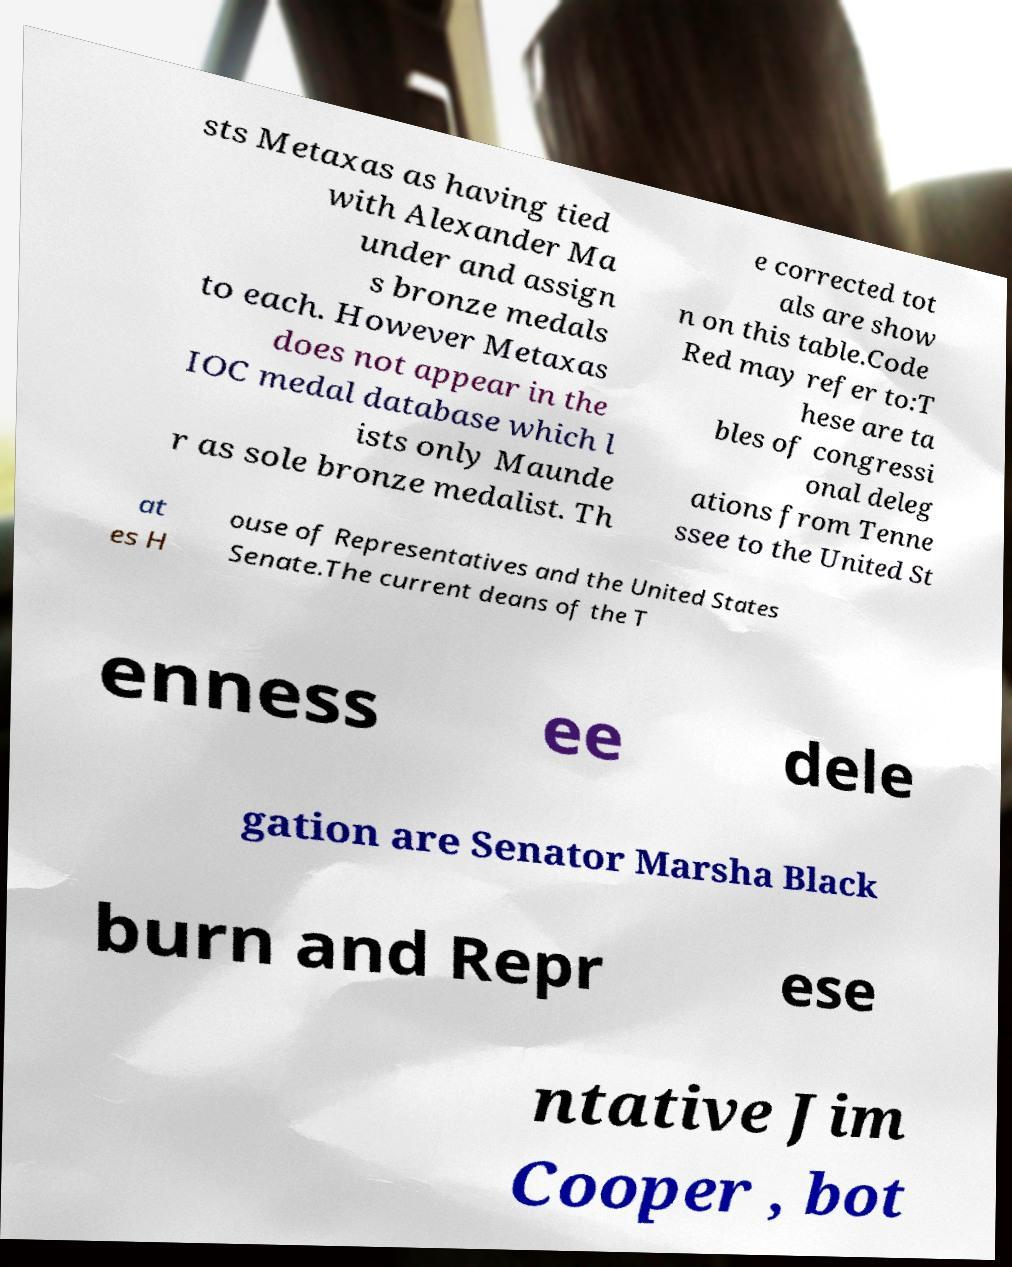What messages or text are displayed in this image? I need them in a readable, typed format. sts Metaxas as having tied with Alexander Ma under and assign s bronze medals to each. However Metaxas does not appear in the IOC medal database which l ists only Maunde r as sole bronze medalist. Th e corrected tot als are show n on this table.Code Red may refer to:T hese are ta bles of congressi onal deleg ations from Tenne ssee to the United St at es H ouse of Representatives and the United States Senate.The current deans of the T enness ee dele gation are Senator Marsha Black burn and Repr ese ntative Jim Cooper , bot 